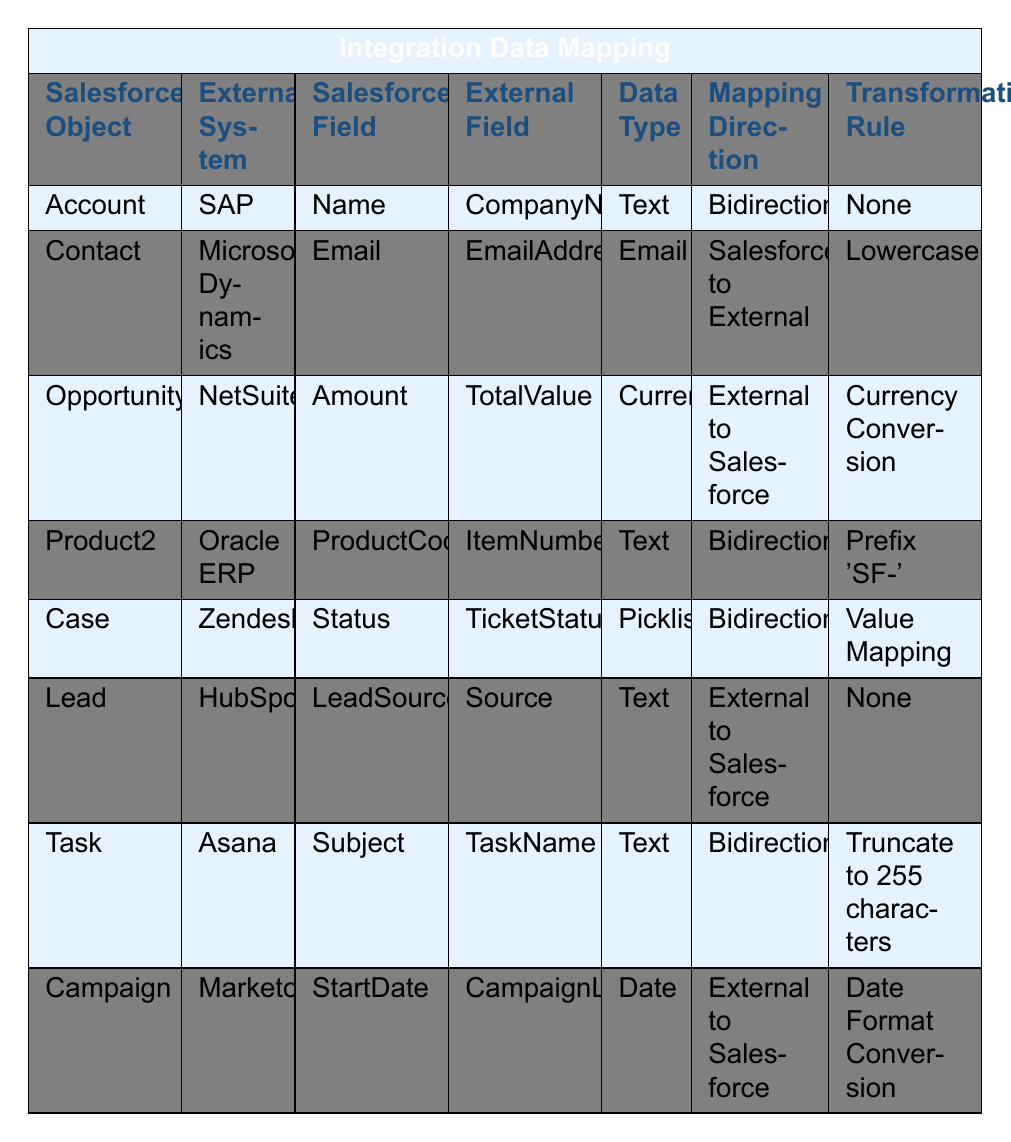What is the Salesforce Field for the Case Salesforce Object? The table indicates that the Salesforce Field for the Case Salesforce Object is "Status."
Answer: Status What is the Mapping Direction for the Opportunity Salesforce Object? According to the table, the Mapping Direction for the Opportunity Salesforce Object is "External to Salesforce."
Answer: External to Salesforce Do all integration mappings involve a transformation rule? The table shows that there are several mappings with "None" as the Transformation Rule, which indicates that not all mappings involve a transformation rule.
Answer: No Which external system is associated with the Lead Salesforce Object? The corresponding row in the table indicates that the external system for the Lead Salesforce Object is "HubSpot."
Answer: HubSpot How many Salesforce Objects have a Mapping Direction of "Bidirectional"? The table lists four Salesforce Objects with "Bidirectional" as the Mapping Direction (Account, Product2, Case, and Task). Therefore, the count is four.
Answer: 4 For which Salesforce Object is the Data Type "Email"? The table specifies that the Data Type "Email" is associated with the Contact Salesforce Object.
Answer: Contact What transformation rule is applied to the Salesforce Field "Email"? The table indicates that the transformation rule for the Salesforce Field "Email" is "Lowercase."
Answer: Lowercase How many Salesforce Objects map to external systems that are specifically Text data types? Upon reviewing the table, there are five Salesforce Objects (Account, Product2, Lead, Task, and the contact itself is technically also Text, but it's Email) with Text data types listed.
Answer: 5 Is there a Salesforce Field for Opportunity that involves currency conversion? The table confirms that the Opportunity Salesforce Field "Amount" is associated with the Transformation Rule "Currency Conversion."
Answer: Yes How does the Transformation Rule for the Task Salesforce Field limit the data? The table states that the Task Salesforce Field "Subject" is constrained by the transformation rule to be "Truncate to 255 characters," which means it will only retain the first 255 characters of data.
Answer: It truncates to 255 characters 